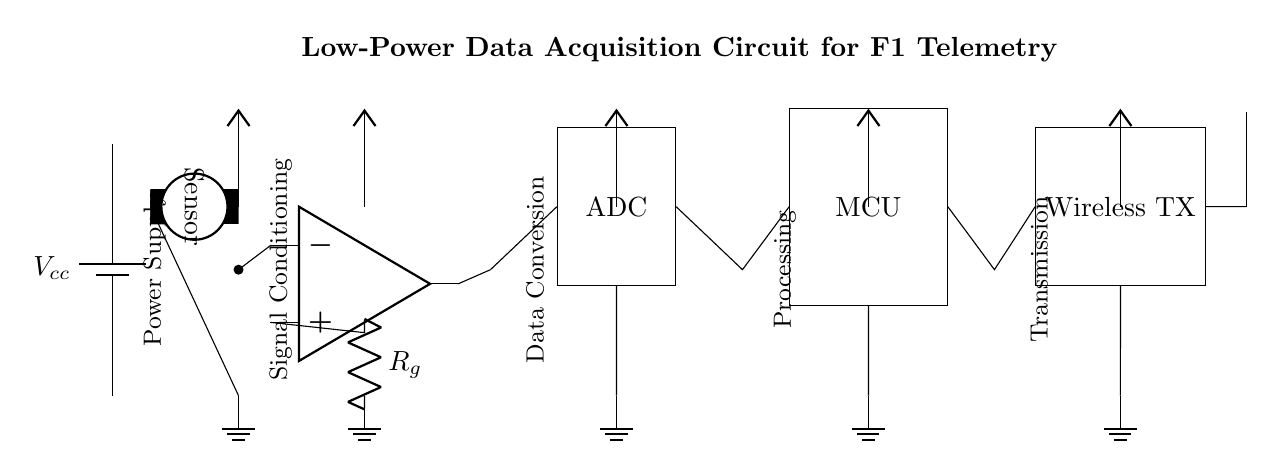What is the main function of the sensor? The sensor's main function is to collect data from its environment, which is crucial for telemetry in Formula One cars.
Answer: Data acquisition What component is used for signal conditioning? The operational amplifier (op amp) performs the signal conditioning, amplifying the sensor output to improve the signal quality before conversion.
Answer: Operational amplifier How many main blocks are present in this circuit? There are five main blocks in this low-power data acquisition circuit: Power Supply, Signal Conditioning, Data Conversion, Processing, and Transmission.
Answer: Five What does the ADC convert? The Analog-to-Digital Converter (ADC) converts the analog signals from the sensor into digital data for processing by the microcontroller.
Answer: Analog signals Which component is responsible for wireless transmission? The wireless transmitter (Wireless TX) is responsible for transmitting the processed telemetry data wirelessly from the microcontroller to receivers.
Answer: Wireless transmitter What role does the microcontroller play in this circuit? The microcontroller (MCU) processes the digital data from the ADC, coordinating the data flow and controlling the wireless transmission module, enabling real-time telemetry.
Answer: Processing What is the purpose of the antenna in this circuit? The antenna is used for transmitting the data wirelessly to other systems, allowing telemetry data to be sent to the pit crew during a race.
Answer: Transmission 